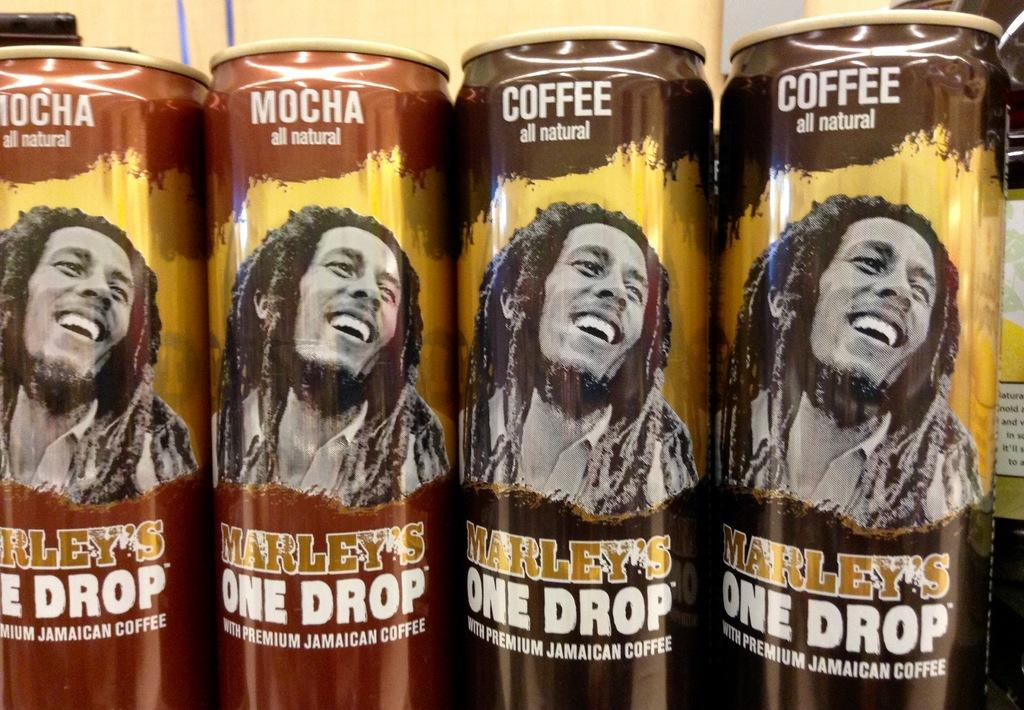<image>
Offer a succinct explanation of the picture presented. A row of canned beverages that say Coffee all natural and have Bob Marley on them. 